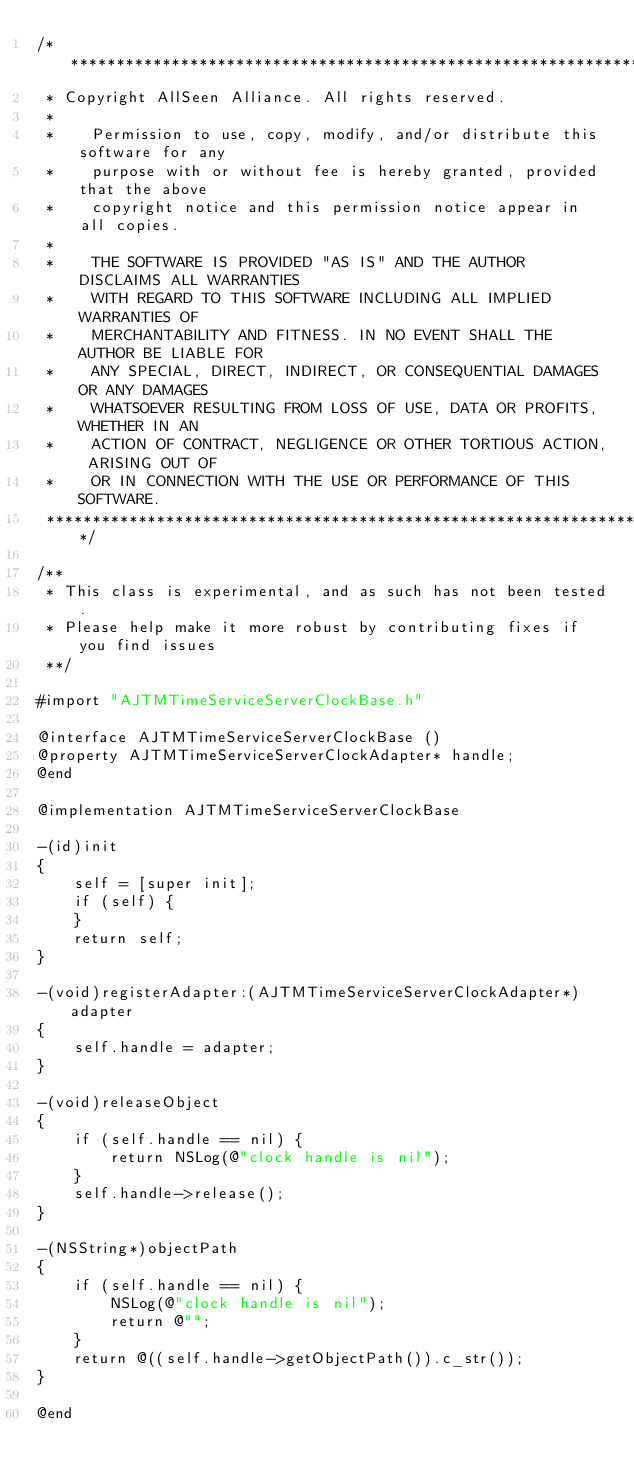<code> <loc_0><loc_0><loc_500><loc_500><_ObjectiveC_>/******************************************************************************
 * Copyright AllSeen Alliance. All rights reserved.
 *
 *    Permission to use, copy, modify, and/or distribute this software for any
 *    purpose with or without fee is hereby granted, provided that the above
 *    copyright notice and this permission notice appear in all copies.
 *
 *    THE SOFTWARE IS PROVIDED "AS IS" AND THE AUTHOR DISCLAIMS ALL WARRANTIES
 *    WITH REGARD TO THIS SOFTWARE INCLUDING ALL IMPLIED WARRANTIES OF
 *    MERCHANTABILITY AND FITNESS. IN NO EVENT SHALL THE AUTHOR BE LIABLE FOR
 *    ANY SPECIAL, DIRECT, INDIRECT, OR CONSEQUENTIAL DAMAGES OR ANY DAMAGES
 *    WHATSOEVER RESULTING FROM LOSS OF USE, DATA OR PROFITS, WHETHER IN AN
 *    ACTION OF CONTRACT, NEGLIGENCE OR OTHER TORTIOUS ACTION, ARISING OUT OF
 *    OR IN CONNECTION WITH THE USE OR PERFORMANCE OF THIS SOFTWARE.
 ******************************************************************************/

/**
 * This class is experimental, and as such has not been tested.
 * Please help make it more robust by contributing fixes if you find issues
 **/

#import "AJTMTimeServiceServerClockBase.h"

@interface AJTMTimeServiceServerClockBase ()
@property AJTMTimeServiceServerClockAdapter* handle;
@end

@implementation AJTMTimeServiceServerClockBase

-(id)init
{
    self = [super init];
    if (self) {
    }
    return self;
}

-(void)registerAdapter:(AJTMTimeServiceServerClockAdapter*) adapter
{
    self.handle = adapter;
}

-(void)releaseObject
{
    if (self.handle == nil) {
        return NSLog(@"clock handle is nil");
    }
    self.handle->release();
}

-(NSString*)objectPath
{
    if (self.handle == nil) {
        NSLog(@"clock handle is nil");
        return @"";
    }
    return @((self.handle->getObjectPath()).c_str()); 
}

@end
</code> 